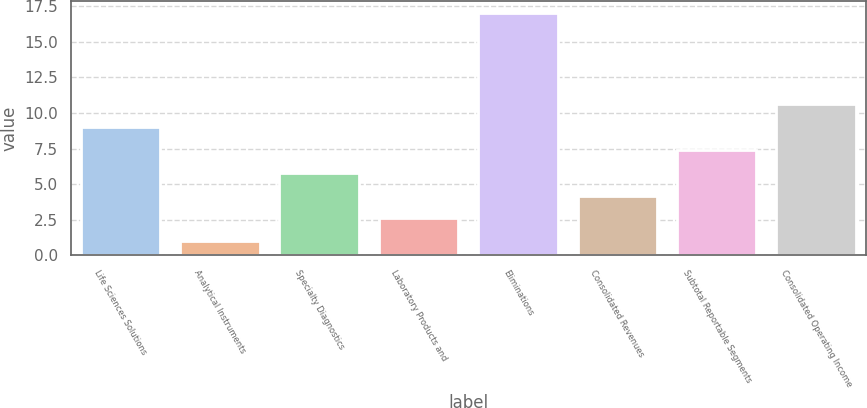Convert chart. <chart><loc_0><loc_0><loc_500><loc_500><bar_chart><fcel>Life Sciences Solutions<fcel>Analytical Instruments<fcel>Specialty Diagnostics<fcel>Laboratory Products and<fcel>Eliminations<fcel>Consolidated Revenues<fcel>Subtotal Reportable Segments<fcel>Consolidated Operating Income<nl><fcel>9<fcel>1<fcel>5.8<fcel>2.6<fcel>17<fcel>4.2<fcel>7.4<fcel>10.6<nl></chart> 